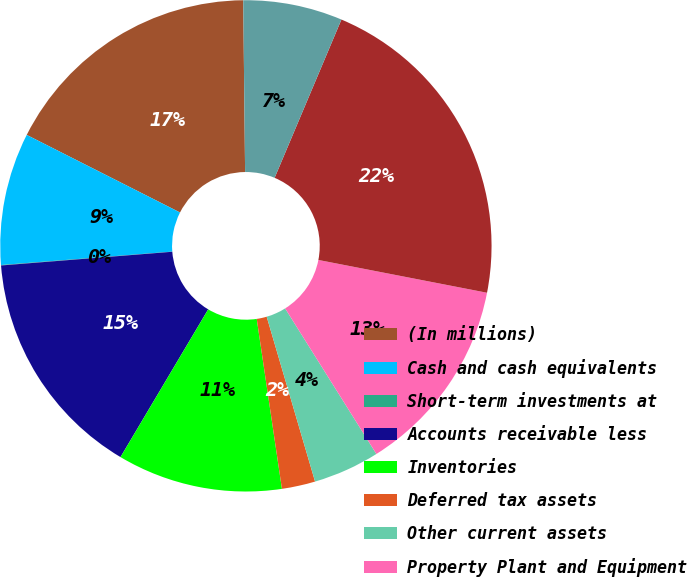<chart> <loc_0><loc_0><loc_500><loc_500><pie_chart><fcel>(In millions)<fcel>Cash and cash equivalents<fcel>Short-term investments at<fcel>Accounts receivable less<fcel>Inventories<fcel>Deferred tax assets<fcel>Other current assets<fcel>Property Plant and Equipment<fcel>Acquisition-related Intangible<fcel>Other Assets<nl><fcel>17.37%<fcel>8.7%<fcel>0.03%<fcel>15.2%<fcel>10.87%<fcel>2.2%<fcel>4.37%<fcel>13.03%<fcel>21.7%<fcel>6.53%<nl></chart> 